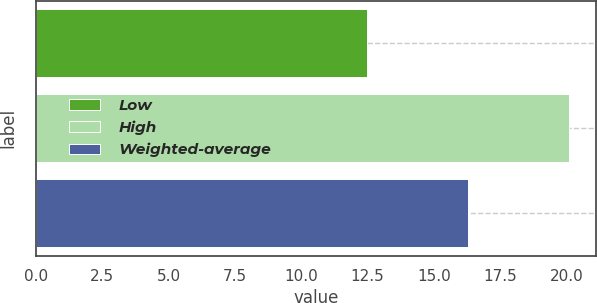Convert chart. <chart><loc_0><loc_0><loc_500><loc_500><bar_chart><fcel>Low<fcel>High<fcel>Weighted-average<nl><fcel>12.5<fcel>20.1<fcel>16.3<nl></chart> 